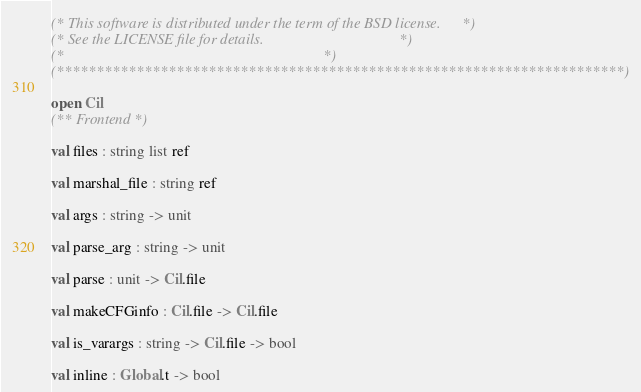Convert code to text. <code><loc_0><loc_0><loc_500><loc_500><_OCaml_>(* This software is distributed under the term of the BSD license.     *)
(* See the LICENSE file for details.                                   *)
(*                                                                     *)
(***********************************************************************)

open Cil
(** Frontend *)

val files : string list ref

val marshal_file : string ref

val args : string -> unit

val parse_arg : string -> unit

val parse : unit -> Cil.file

val makeCFGinfo : Cil.file -> Cil.file

val is_varargs : string -> Cil.file -> bool

val inline : Global.t -> bool
</code> 